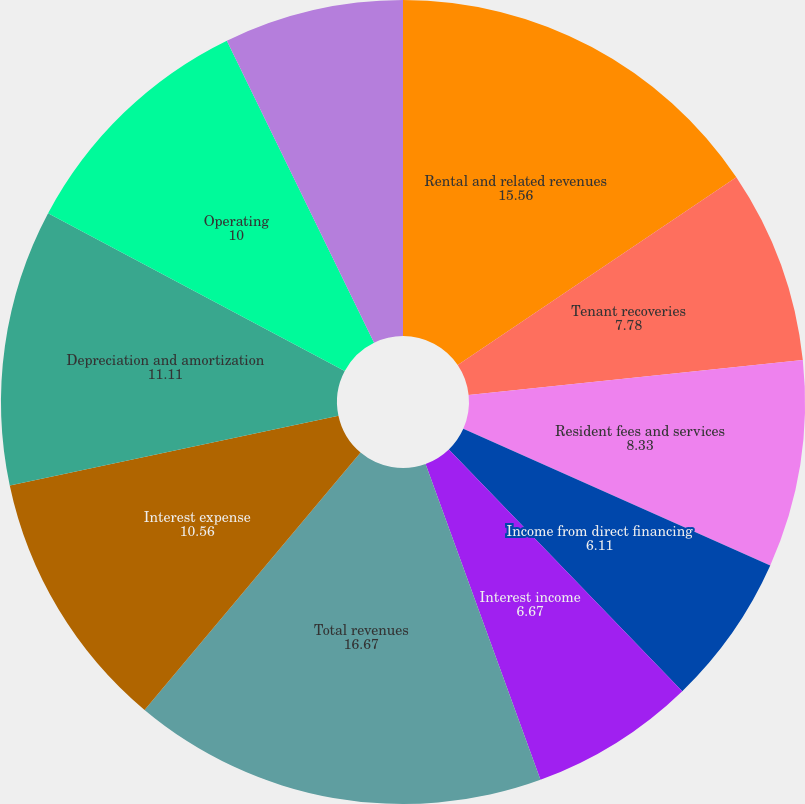Convert chart to OTSL. <chart><loc_0><loc_0><loc_500><loc_500><pie_chart><fcel>Rental and related revenues<fcel>Tenant recoveries<fcel>Resident fees and services<fcel>Income from direct financing<fcel>Interest income<fcel>Total revenues<fcel>Interest expense<fcel>Depreciation and amortization<fcel>Operating<fcel>General and administrative<nl><fcel>15.56%<fcel>7.78%<fcel>8.33%<fcel>6.11%<fcel>6.67%<fcel>16.67%<fcel>10.56%<fcel>11.11%<fcel>10.0%<fcel>7.22%<nl></chart> 